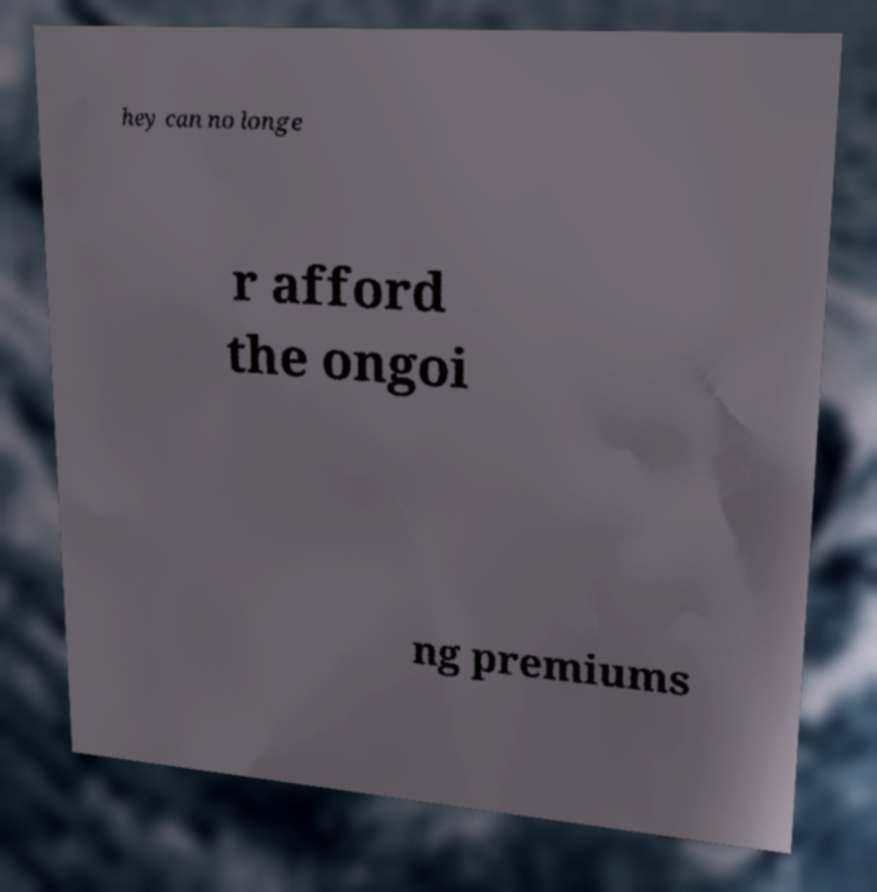What messages or text are displayed in this image? I need them in a readable, typed format. hey can no longe r afford the ongoi ng premiums 